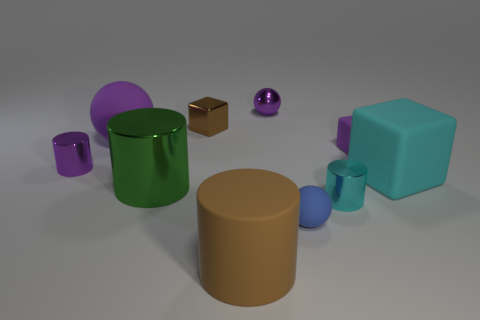Subtract all shiny balls. How many balls are left? 2 Subtract all cyan cylinders. How many purple balls are left? 2 Subtract all purple blocks. How many blocks are left? 2 Subtract all cylinders. How many objects are left? 6 Subtract 1 spheres. How many spheres are left? 2 Add 4 large rubber balls. How many large rubber balls exist? 5 Subtract 0 red cylinders. How many objects are left? 10 Subtract all purple spheres. Subtract all green cylinders. How many spheres are left? 1 Subtract all purple spheres. Subtract all tiny yellow rubber cylinders. How many objects are left? 8 Add 7 cyan metallic objects. How many cyan metallic objects are left? 8 